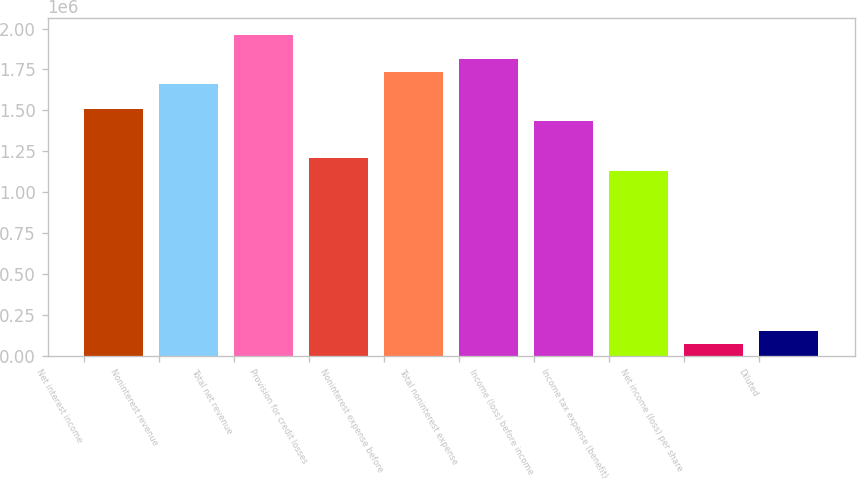Convert chart to OTSL. <chart><loc_0><loc_0><loc_500><loc_500><bar_chart><fcel>Net interest income<fcel>Noninterest revenue<fcel>Total net revenue<fcel>Provision for credit losses<fcel>Noninterest expense before<fcel>Total noninterest expense<fcel>Income (loss) before income<fcel>Income tax expense (benefit)<fcel>Net income (loss) per share<fcel>Diluted<nl><fcel>1.51031e+06<fcel>1.66134e+06<fcel>1.96341e+06<fcel>1.20825e+06<fcel>1.73686e+06<fcel>1.81237e+06<fcel>1.4348e+06<fcel>1.13273e+06<fcel>75515.9<fcel>151031<nl></chart> 